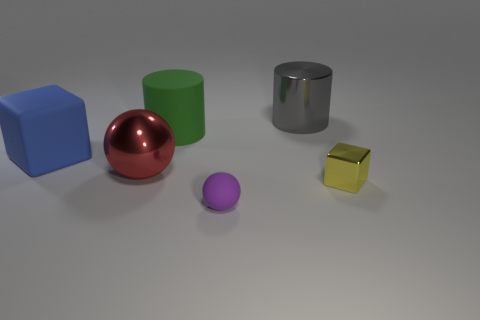Add 2 big green matte blocks. How many objects exist? 8 Subtract all cylinders. How many objects are left? 4 Add 1 blue objects. How many blue objects are left? 2 Add 3 large things. How many large things exist? 7 Subtract 0 yellow balls. How many objects are left? 6 Subtract all purple cylinders. Subtract all green spheres. How many cylinders are left? 2 Subtract all large gray metallic cylinders. Subtract all gray metal cylinders. How many objects are left? 4 